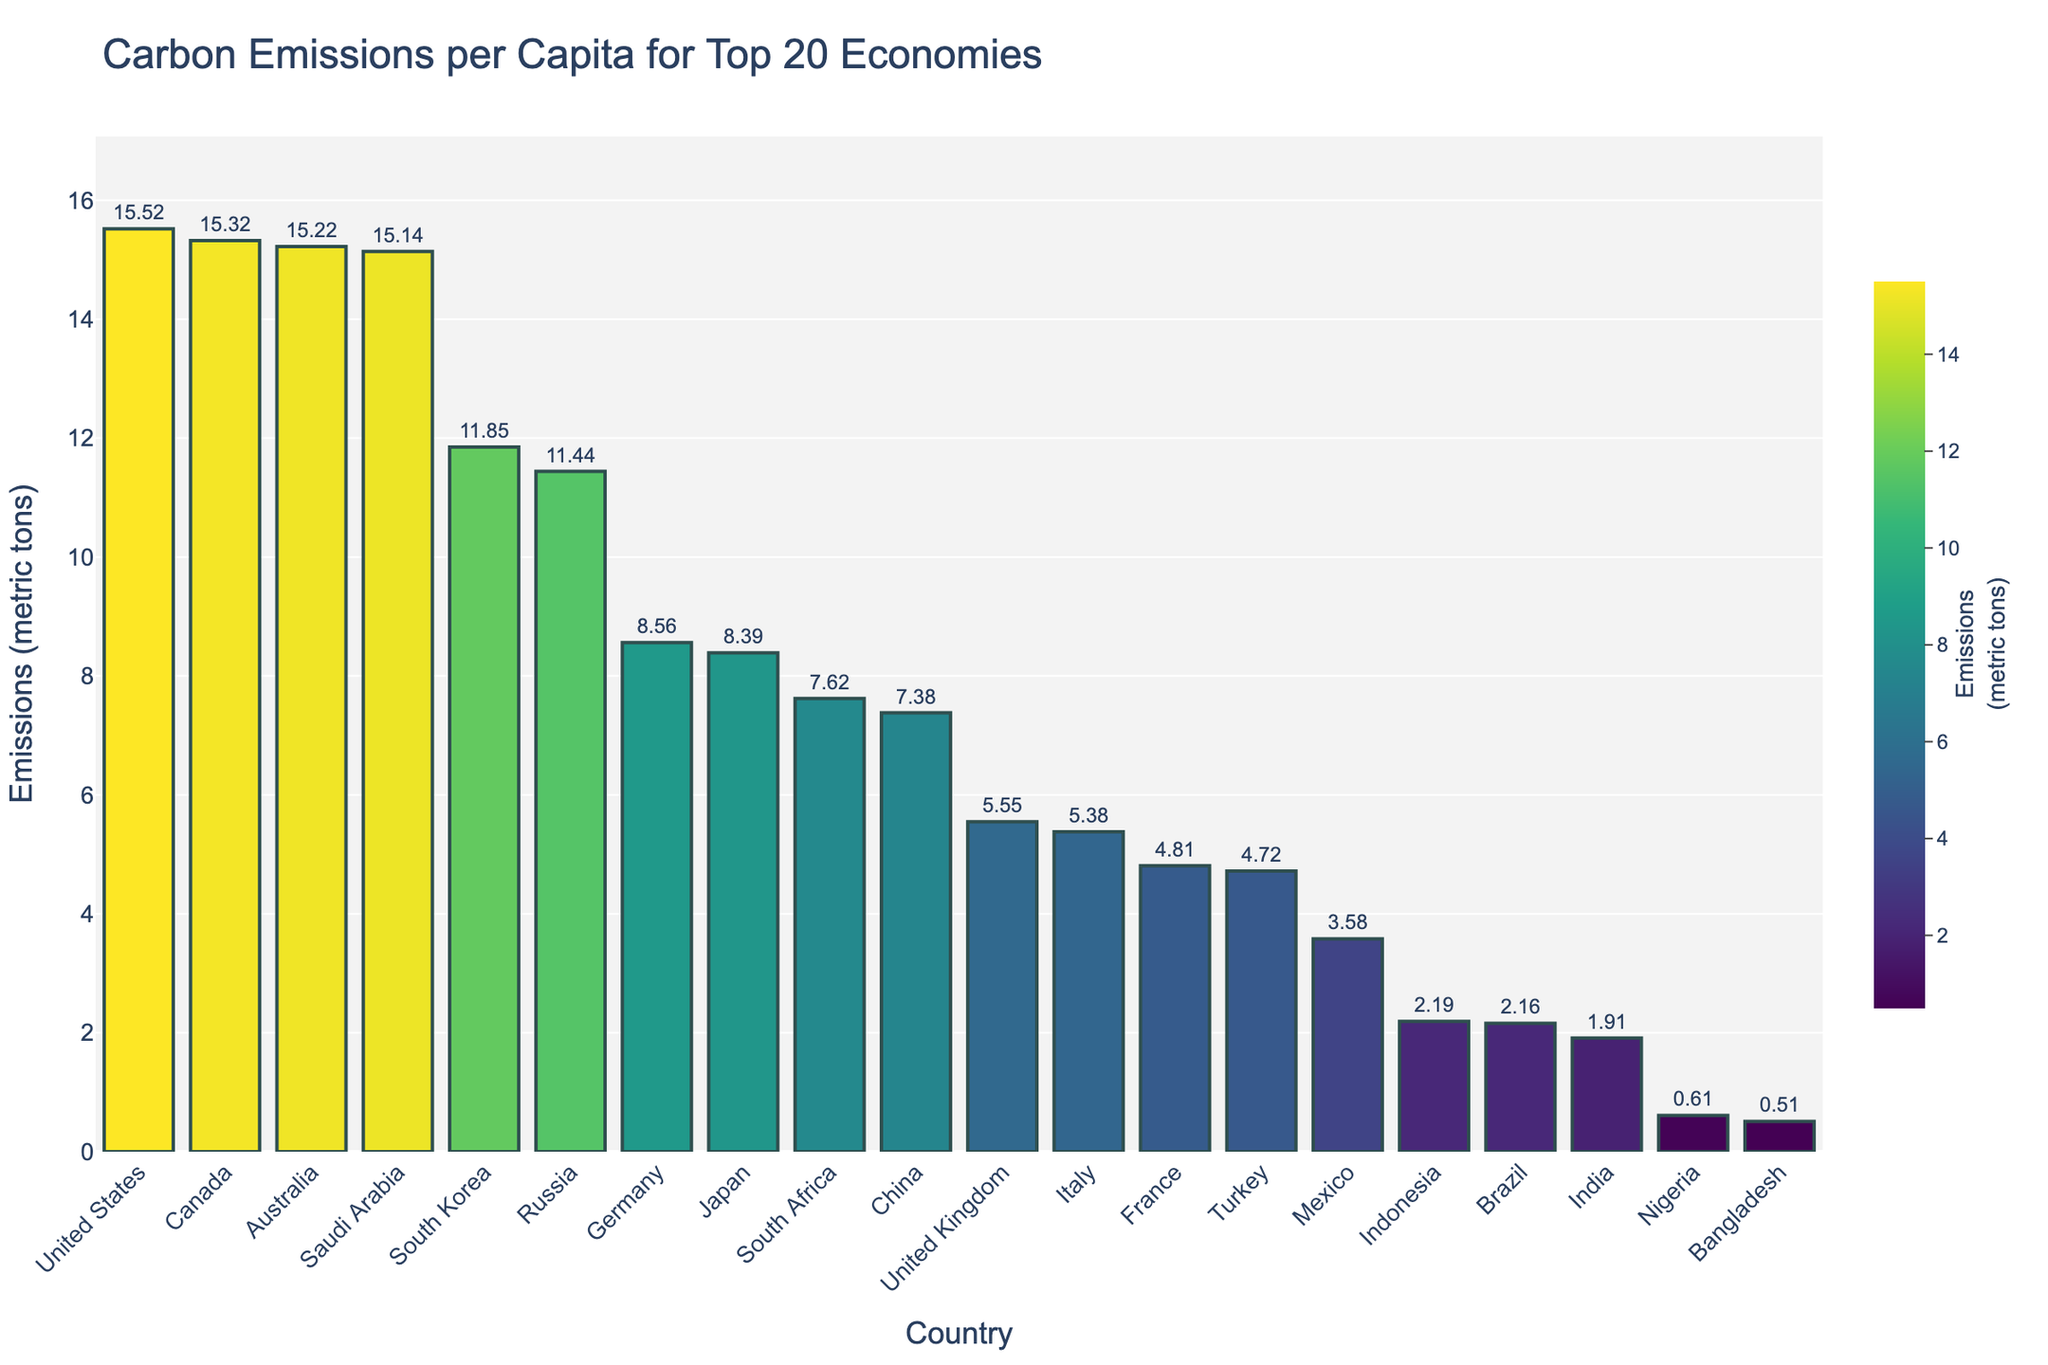Which country has the highest carbon emissions per capita? The United States has the bar reaching the highest value on the y-axis, which represents carbon emissions per capita.
Answer: United States Which country has the lowest carbon emissions per capita? Bangladesh has the shortest bar, indicating the lowest carbon emissions per capita among the top 20 economies.
Answer: Bangladesh How much higher are the carbon emissions per capita in the United States compared to China? The United States has 15.52 metric tons per capita, and China has 7.38 metric tons per capita. The difference is 15.52 - 7.38 = 8.14 metric tons.
Answer: 8.14 metric tons What is the average carbon emissions per capita for the top 5 countries? The top 5 countries are the United States (15.52), Canada (15.32), Australia (15.22), Saudi Arabia (15.14), and South Korea (11.85). The average is (15.52 + 15.32 + 15.22 + 15.14 + 11.85) / 5 = 72.05 / 5 = 14.41 metric tons.
Answer: 14.41 metric tons Which country contributes more to carbon emissions per capita, Germany or Japan? Germany's bar reaches 8.56 metric tons, while Japan's bar is slightly lower at 8.39 metric tons. Therefore, Germany has higher carbon emissions per capita than Japan.
Answer: Germany Are there any European countries with carbon emissions per capita above 10 metric tons? By examining the bars for European countries (Germany, United Kingdom, Italy, France), none of them reach the 10 metric tons mark.
Answer: No Compare the carbon emissions per capita of Brazil and India. Which country has lower emissions? Brazil's bar reaches 2.16 metric tons, while India's bar is slightly lower at 1.91 metric tons. Therefore, India has lower carbon emissions per capita than Brazil.
Answer: India What is the combined carbon emissions per capita for Italy and France? Italy has 5.38 metric tons, and France has 4.81 metric tons. Their combined emissions are 5.38 + 4.81 = 10.19 metric tons.
Answer: 10.19 metric tons Which two countries have nearly equal carbon emissions per capita? Canada and Australia have very similar bars, indicating nearly equal carbon emissions per capita (Canada: 15.32, Australia: 15.22).
Answer: Canada and Australia How does the carbon emissions per capita of Mexico compare to the global average within the top 20 economies? Mexico's emissions per capita are 3.58 metric tons. To find the global average, sum all values and divide by the number of countries (20). The global average is approximately 6.58 metric tons, so Mexico's value is lower than this average.
Answer: Lower 